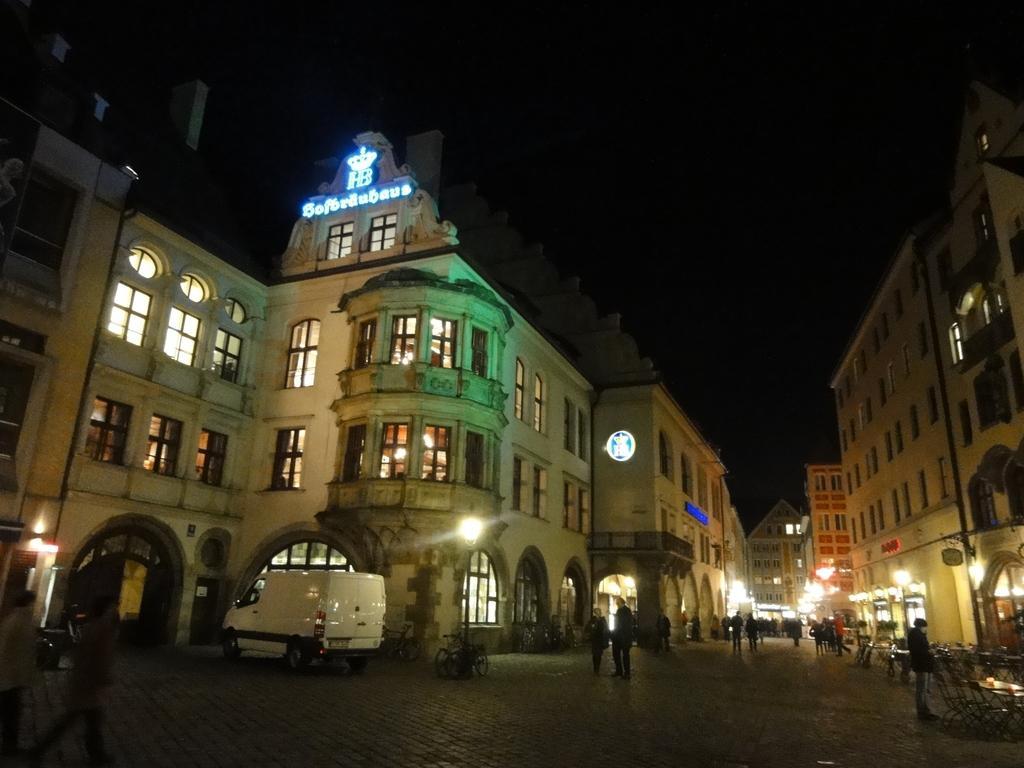Please provide a concise description of this image. In this picture I can see vehicles, group of people standing, there are poles, lights, buildings, chairs, tables. 